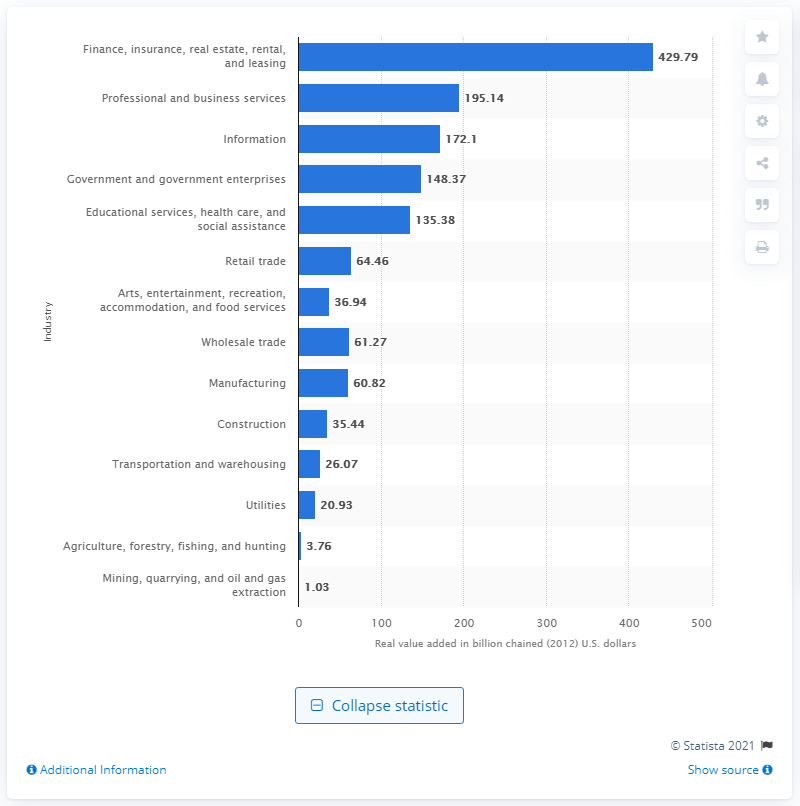Specify some key components in this picture. In 2020, the mining industry contributed 1.03 times the state GDP through the addition of chain-dollar value. 